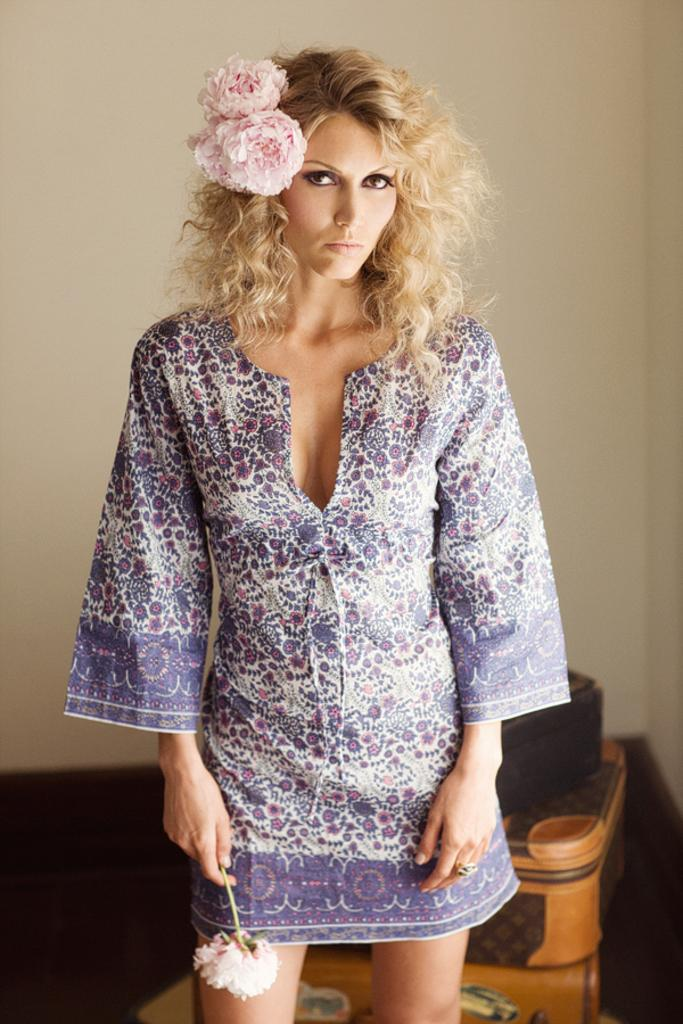Who is present in the image? There is a woman in the image. What is the woman doing in the image? The woman is standing in the image. What is the woman holding in the image? The woman is holding a flower in the image. What can be seen in the background of the image? There is a wall in the background of the image. What object is located at the bottom of the image? There appears to be a box at the bottom of the image. What type of berry can be seen growing on the wall in the image? There are no berries visible in the image, and the wall does not have any plants or vegetation growing on it. 